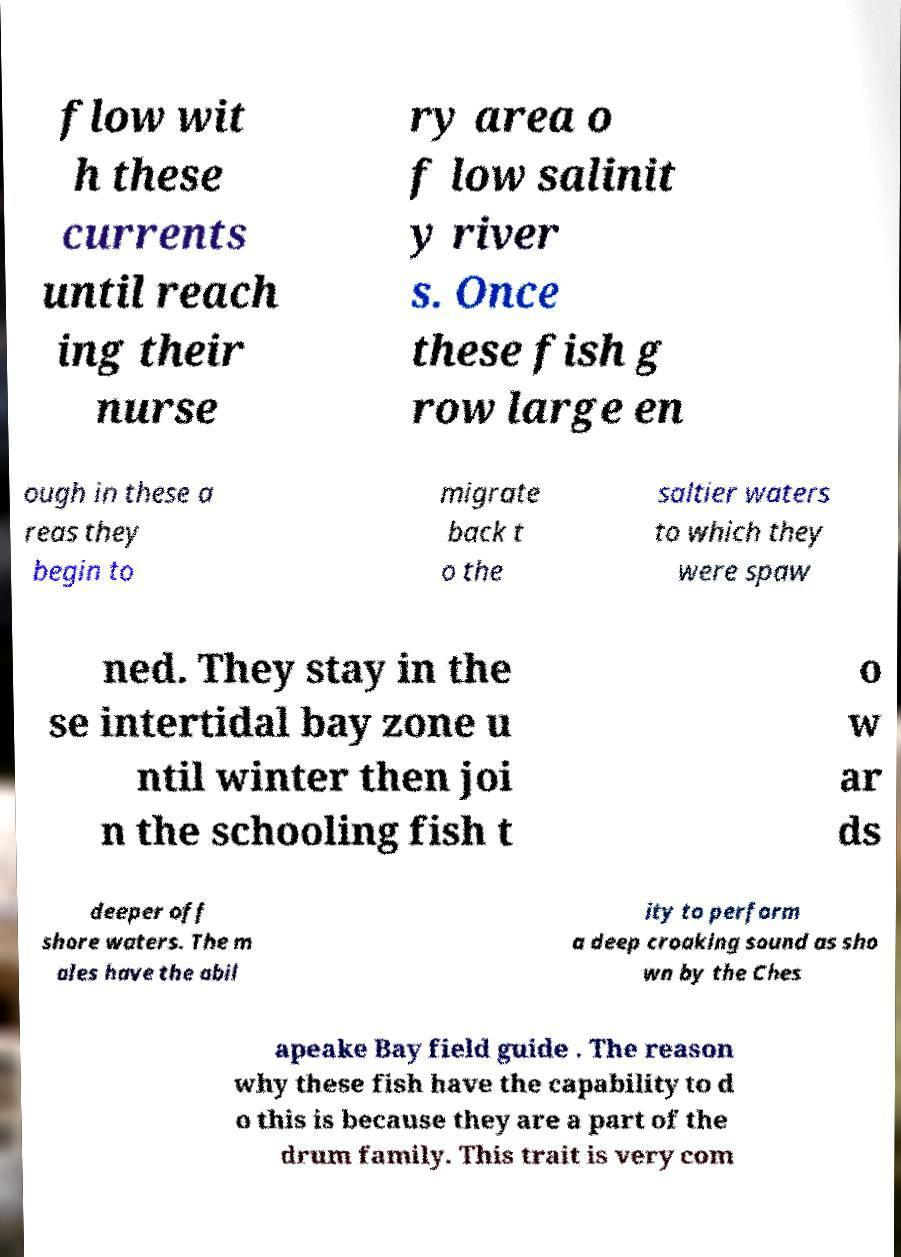For documentation purposes, I need the text within this image transcribed. Could you provide that? flow wit h these currents until reach ing their nurse ry area o f low salinit y river s. Once these fish g row large en ough in these a reas they begin to migrate back t o the saltier waters to which they were spaw ned. They stay in the se intertidal bay zone u ntil winter then joi n the schooling fish t o w ar ds deeper off shore waters. The m ales have the abil ity to perform a deep croaking sound as sho wn by the Ches apeake Bay field guide . The reason why these fish have the capability to d o this is because they are a part of the drum family. This trait is very com 